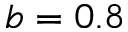Convert formula to latex. <formula><loc_0><loc_0><loc_500><loc_500>b = 0 . 8</formula> 